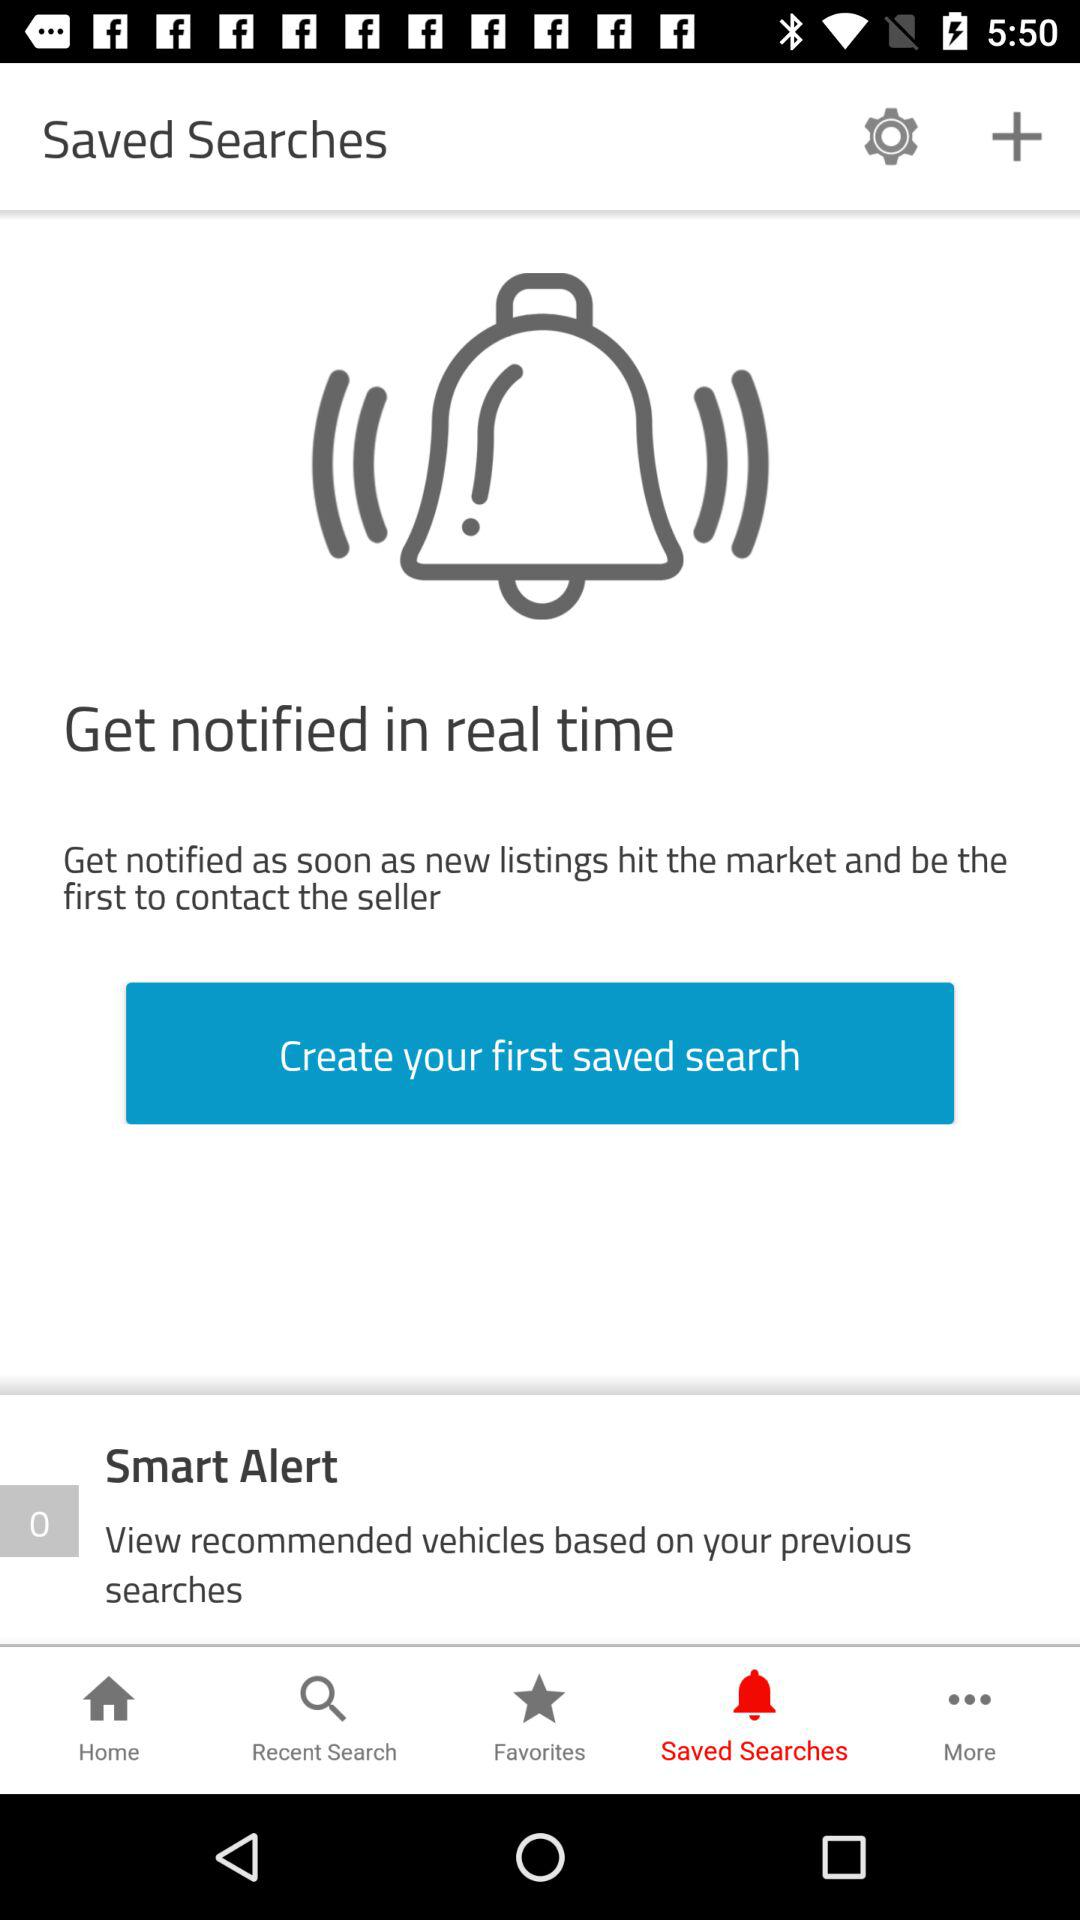Which tab is selected? The selected tab is "Saved Searches". 